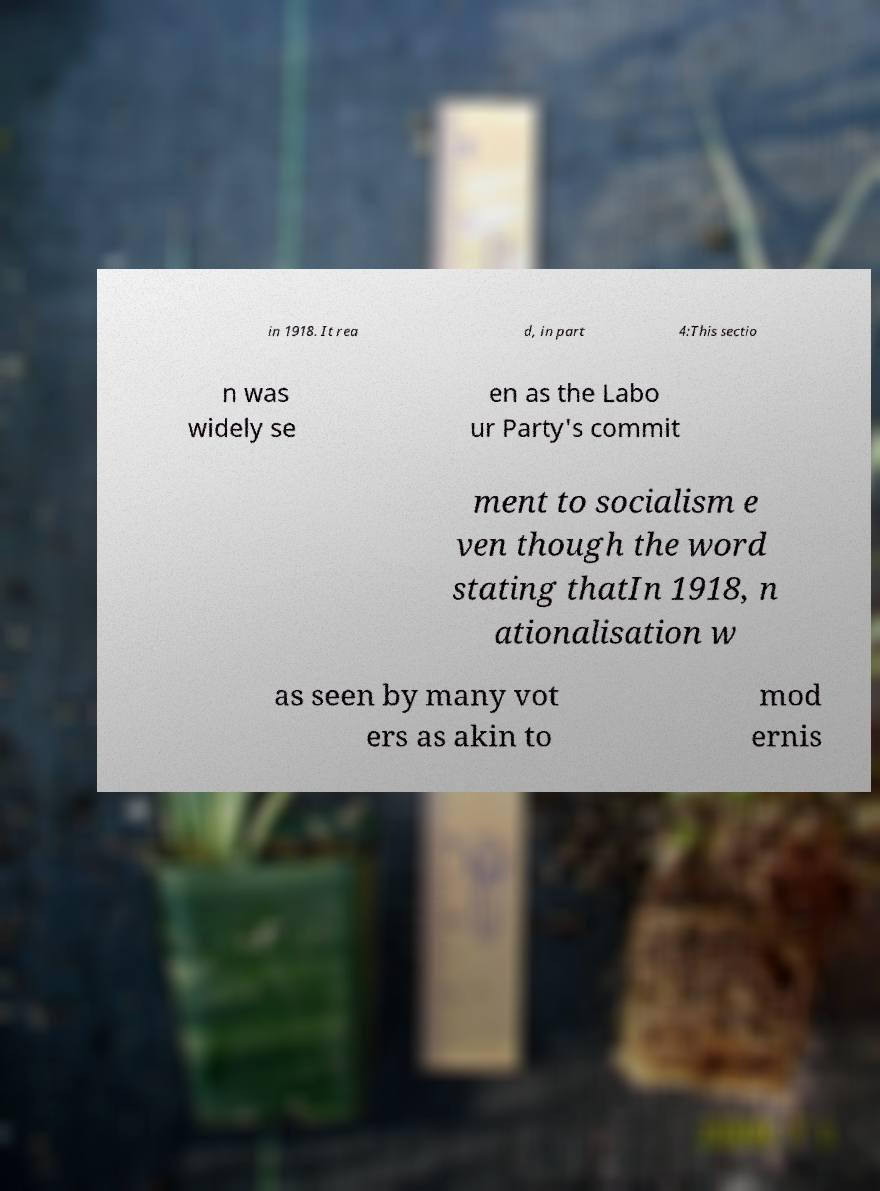Can you read and provide the text displayed in the image?This photo seems to have some interesting text. Can you extract and type it out for me? in 1918. It rea d, in part 4:This sectio n was widely se en as the Labo ur Party's commit ment to socialism e ven though the word stating thatIn 1918, n ationalisation w as seen by many vot ers as akin to mod ernis 